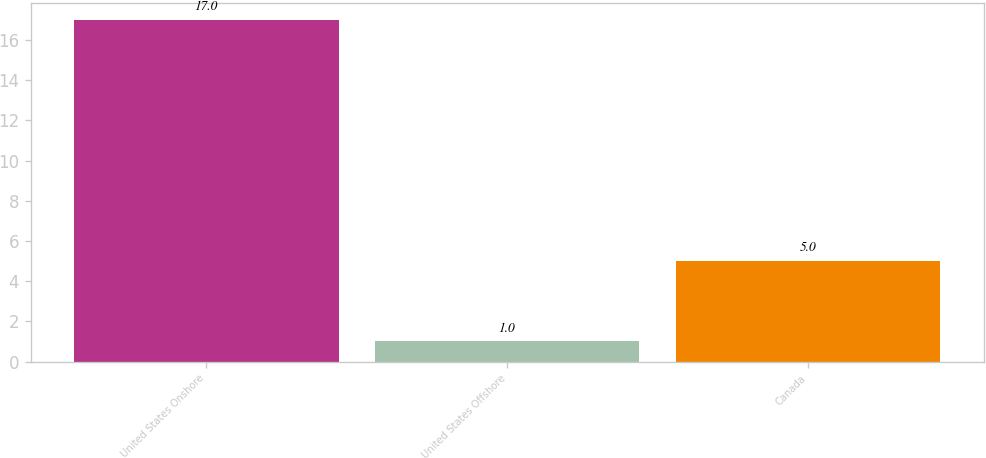Convert chart. <chart><loc_0><loc_0><loc_500><loc_500><bar_chart><fcel>United States Onshore<fcel>United States Offshore<fcel>Canada<nl><fcel>17<fcel>1<fcel>5<nl></chart> 